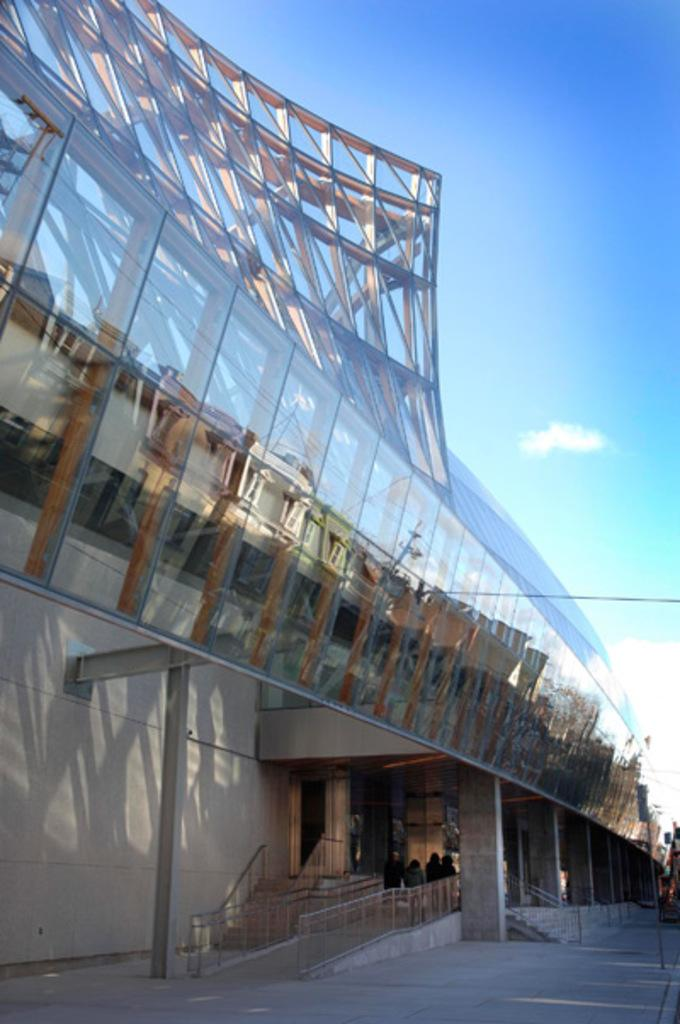What type of building is shown in the image? The image depicts an architectural building with glass elements. What structural features can be seen on the building? The building has pillars. Are there any people present in the image? Yes, there are people standing near the building. What else can be seen in the image besides the building and people? There is a pole in the image. What is visible in the background of the image? The sky is visible in the image. What are the children writing on the building in the image? There are no children present in the image, and therefore no writing on the building can be observed. How do the people in the image maintain their balance while standing near the building? There is no information provided about the people's balance in the image, and it is not possible to determine this from the image alone. 